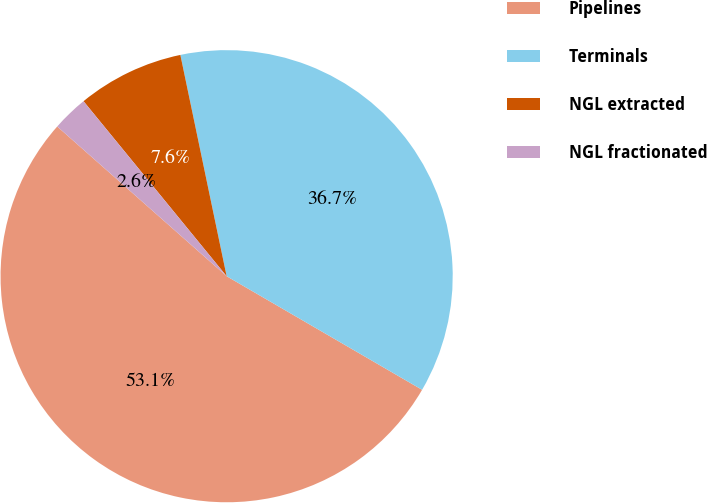Convert chart. <chart><loc_0><loc_0><loc_500><loc_500><pie_chart><fcel>Pipelines<fcel>Terminals<fcel>NGL extracted<fcel>NGL fractionated<nl><fcel>53.14%<fcel>36.66%<fcel>7.63%<fcel>2.57%<nl></chart> 